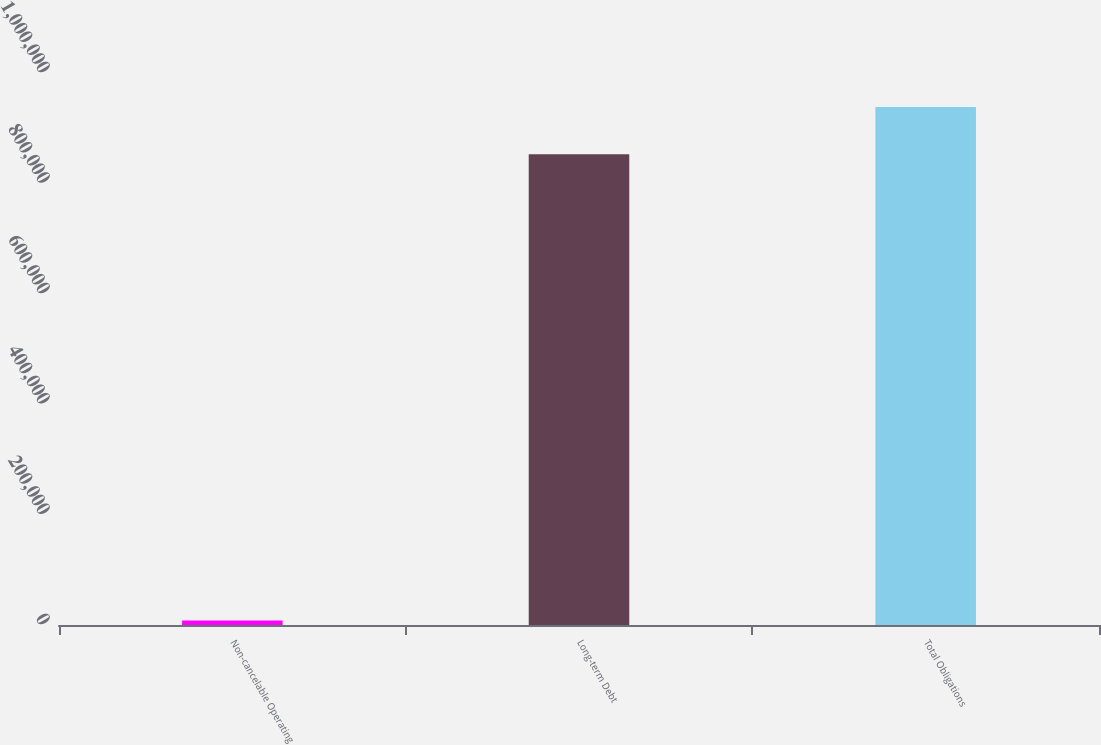<chart> <loc_0><loc_0><loc_500><loc_500><bar_chart><fcel>Non-cancelable Operating<fcel>Long-term Debt<fcel>Total Obligations<nl><fcel>7937<fcel>852992<fcel>938291<nl></chart> 